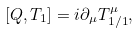Convert formula to latex. <formula><loc_0><loc_0><loc_500><loc_500>[ Q , T _ { 1 } ] = i \partial _ { \mu } T ^ { \mu } _ { 1 / 1 } ,</formula> 